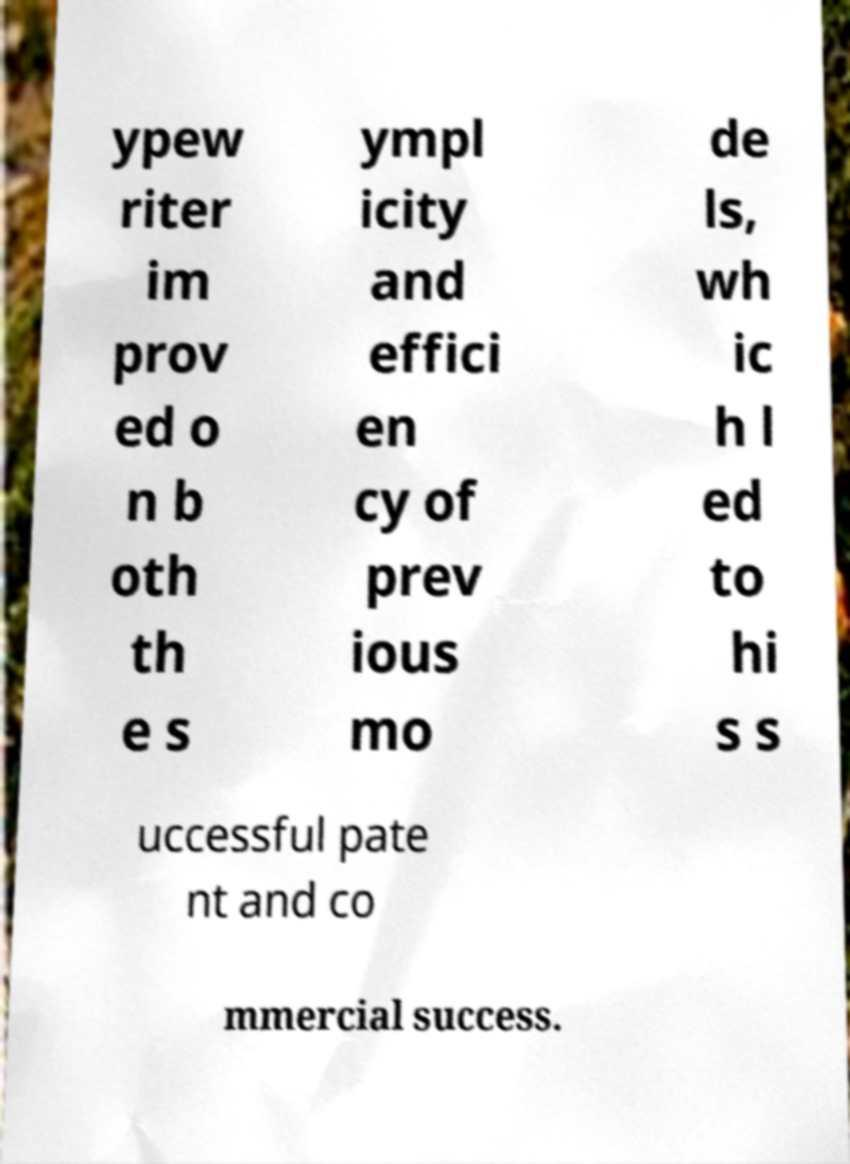What messages or text are displayed in this image? I need them in a readable, typed format. ypew riter im prov ed o n b oth th e s ympl icity and effici en cy of prev ious mo de ls, wh ic h l ed to hi s s uccessful pate nt and co mmercial success. 